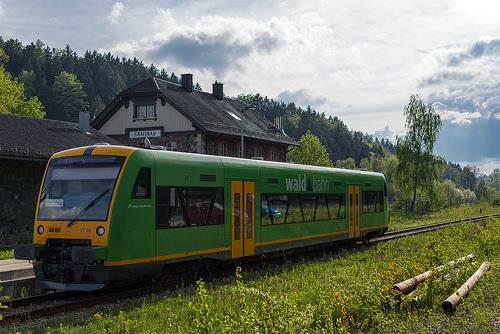Explain briefly the appearance and location of any buildings in the image. There is a building with a dark brown roof and a chimney located in the background behind the train. Mention the distinct colors seen on the train and its surroundings. The train is green and yellow, with surrounding elements such as brown logs, a green tree, a brown roof, and green bushes. Summarize the overall setting and atmosphere of the image. The image shows a green and yellow passenger train moving through a rural, forested setting on a bright, cloudy day. Give a brief description of the type of train and the environment it's moving through. This is a green and yellow passenger train moving through a rural setting adjacent to a forest. Describe the notable features of the train's facade. The train has a windshield with a black wiper, square window, yellow doors, and white writing on its side. List the natural elements visible near the train tracks. Near the train tracks, there are logs, wildflowers, small plants, and a tall green tree. Identify the primary mode of transportation seen in the image and its colors. The image features a green and yellow train moving along train tracks. Mention any small details present on the train's windshield and doors. The train's windshield has a black wiper, and the doors are painted in yellow. Describe any nearby objects placed on the ground close to the train tracks. There are two brown logs lying in the grass close to the train tracks. Outline the main elements near the train tracks and their colors. Beside the train tracks, there are green bushes, brown logs, and a tall tree, as well as a building with a brown roof. 